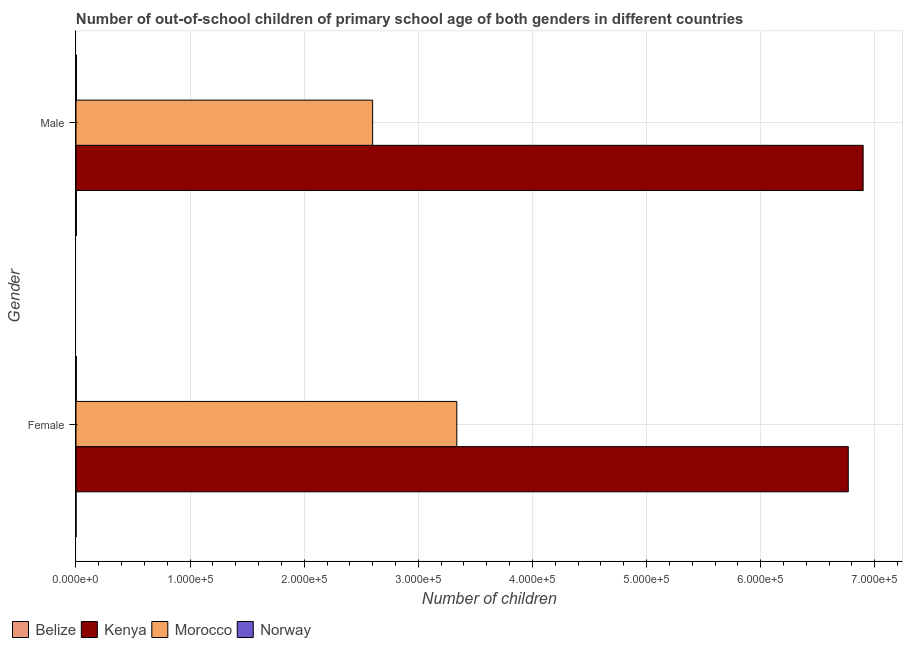How many different coloured bars are there?
Your answer should be very brief. 4. Are the number of bars per tick equal to the number of legend labels?
Keep it short and to the point. Yes. How many bars are there on the 1st tick from the bottom?
Keep it short and to the point. 4. What is the number of female out-of-school students in Morocco?
Ensure brevity in your answer.  3.34e+05. Across all countries, what is the maximum number of male out-of-school students?
Offer a very short reply. 6.90e+05. Across all countries, what is the minimum number of female out-of-school students?
Give a very brief answer. 33. In which country was the number of male out-of-school students maximum?
Provide a succinct answer. Kenya. In which country was the number of female out-of-school students minimum?
Provide a short and direct response. Belize. What is the total number of male out-of-school students in the graph?
Give a very brief answer. 9.50e+05. What is the difference between the number of male out-of-school students in Kenya and that in Norway?
Your answer should be compact. 6.89e+05. What is the difference between the number of male out-of-school students in Kenya and the number of female out-of-school students in Belize?
Offer a terse response. 6.90e+05. What is the average number of male out-of-school students per country?
Your answer should be very brief. 2.38e+05. What is the difference between the number of female out-of-school students and number of male out-of-school students in Norway?
Give a very brief answer. -90. What is the ratio of the number of male out-of-school students in Norway to that in Morocco?
Your answer should be compact. 0. In how many countries, is the number of male out-of-school students greater than the average number of male out-of-school students taken over all countries?
Your response must be concise. 2. What does the 4th bar from the top in Female represents?
Give a very brief answer. Belize. What does the 1st bar from the bottom in Female represents?
Offer a very short reply. Belize. Are all the bars in the graph horizontal?
Provide a succinct answer. Yes. How many countries are there in the graph?
Offer a terse response. 4. What is the difference between two consecutive major ticks on the X-axis?
Ensure brevity in your answer.  1.00e+05. Are the values on the major ticks of X-axis written in scientific E-notation?
Your answer should be very brief. Yes. What is the title of the graph?
Ensure brevity in your answer.  Number of out-of-school children of primary school age of both genders in different countries. What is the label or title of the X-axis?
Your response must be concise. Number of children. What is the Number of children in Belize in Female?
Your answer should be very brief. 33. What is the Number of children of Kenya in Female?
Your answer should be compact. 6.77e+05. What is the Number of children of Morocco in Female?
Your answer should be very brief. 3.34e+05. What is the Number of children in Norway in Female?
Ensure brevity in your answer.  267. What is the Number of children of Belize in Male?
Give a very brief answer. 355. What is the Number of children in Kenya in Male?
Give a very brief answer. 6.90e+05. What is the Number of children in Morocco in Male?
Provide a short and direct response. 2.60e+05. What is the Number of children of Norway in Male?
Provide a short and direct response. 357. Across all Gender, what is the maximum Number of children of Belize?
Provide a short and direct response. 355. Across all Gender, what is the maximum Number of children in Kenya?
Make the answer very short. 6.90e+05. Across all Gender, what is the maximum Number of children of Morocco?
Offer a very short reply. 3.34e+05. Across all Gender, what is the maximum Number of children in Norway?
Offer a terse response. 357. Across all Gender, what is the minimum Number of children of Belize?
Offer a terse response. 33. Across all Gender, what is the minimum Number of children in Kenya?
Ensure brevity in your answer.  6.77e+05. Across all Gender, what is the minimum Number of children in Morocco?
Give a very brief answer. 2.60e+05. Across all Gender, what is the minimum Number of children of Norway?
Make the answer very short. 267. What is the total Number of children in Belize in the graph?
Your answer should be very brief. 388. What is the total Number of children in Kenya in the graph?
Provide a succinct answer. 1.37e+06. What is the total Number of children of Morocco in the graph?
Ensure brevity in your answer.  5.94e+05. What is the total Number of children in Norway in the graph?
Keep it short and to the point. 624. What is the difference between the Number of children in Belize in Female and that in Male?
Your answer should be compact. -322. What is the difference between the Number of children of Kenya in Female and that in Male?
Provide a short and direct response. -1.30e+04. What is the difference between the Number of children of Morocco in Female and that in Male?
Your answer should be very brief. 7.38e+04. What is the difference between the Number of children of Norway in Female and that in Male?
Offer a terse response. -90. What is the difference between the Number of children in Belize in Female and the Number of children in Kenya in Male?
Ensure brevity in your answer.  -6.90e+05. What is the difference between the Number of children in Belize in Female and the Number of children in Morocco in Male?
Provide a short and direct response. -2.60e+05. What is the difference between the Number of children of Belize in Female and the Number of children of Norway in Male?
Give a very brief answer. -324. What is the difference between the Number of children of Kenya in Female and the Number of children of Morocco in Male?
Keep it short and to the point. 4.17e+05. What is the difference between the Number of children in Kenya in Female and the Number of children in Norway in Male?
Your answer should be compact. 6.76e+05. What is the difference between the Number of children of Morocco in Female and the Number of children of Norway in Male?
Provide a succinct answer. 3.33e+05. What is the average Number of children in Belize per Gender?
Offer a very short reply. 194. What is the average Number of children of Kenya per Gender?
Provide a short and direct response. 6.83e+05. What is the average Number of children of Morocco per Gender?
Give a very brief answer. 2.97e+05. What is the average Number of children of Norway per Gender?
Make the answer very short. 312. What is the difference between the Number of children in Belize and Number of children in Kenya in Female?
Give a very brief answer. -6.77e+05. What is the difference between the Number of children in Belize and Number of children in Morocco in Female?
Your answer should be very brief. -3.34e+05. What is the difference between the Number of children of Belize and Number of children of Norway in Female?
Provide a succinct answer. -234. What is the difference between the Number of children in Kenya and Number of children in Morocco in Female?
Make the answer very short. 3.43e+05. What is the difference between the Number of children in Kenya and Number of children in Norway in Female?
Offer a terse response. 6.77e+05. What is the difference between the Number of children in Morocco and Number of children in Norway in Female?
Your answer should be compact. 3.33e+05. What is the difference between the Number of children of Belize and Number of children of Kenya in Male?
Your answer should be very brief. -6.89e+05. What is the difference between the Number of children of Belize and Number of children of Morocco in Male?
Ensure brevity in your answer.  -2.60e+05. What is the difference between the Number of children in Kenya and Number of children in Morocco in Male?
Make the answer very short. 4.30e+05. What is the difference between the Number of children of Kenya and Number of children of Norway in Male?
Offer a terse response. 6.89e+05. What is the difference between the Number of children of Morocco and Number of children of Norway in Male?
Ensure brevity in your answer.  2.60e+05. What is the ratio of the Number of children of Belize in Female to that in Male?
Provide a succinct answer. 0.09. What is the ratio of the Number of children in Kenya in Female to that in Male?
Offer a very short reply. 0.98. What is the ratio of the Number of children of Morocco in Female to that in Male?
Ensure brevity in your answer.  1.28. What is the ratio of the Number of children in Norway in Female to that in Male?
Make the answer very short. 0.75. What is the difference between the highest and the second highest Number of children in Belize?
Keep it short and to the point. 322. What is the difference between the highest and the second highest Number of children of Kenya?
Give a very brief answer. 1.30e+04. What is the difference between the highest and the second highest Number of children in Morocco?
Offer a very short reply. 7.38e+04. What is the difference between the highest and the lowest Number of children of Belize?
Offer a terse response. 322. What is the difference between the highest and the lowest Number of children of Kenya?
Ensure brevity in your answer.  1.30e+04. What is the difference between the highest and the lowest Number of children in Morocco?
Keep it short and to the point. 7.38e+04. 